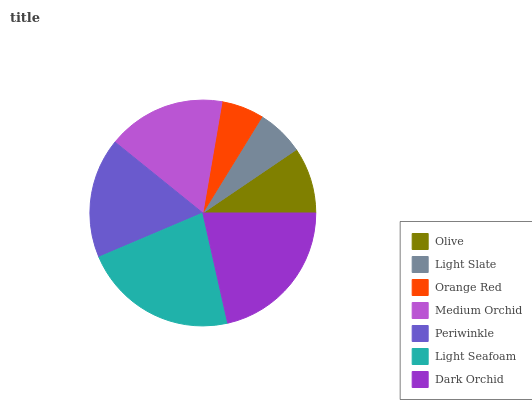Is Orange Red the minimum?
Answer yes or no. Yes. Is Light Seafoam the maximum?
Answer yes or no. Yes. Is Light Slate the minimum?
Answer yes or no. No. Is Light Slate the maximum?
Answer yes or no. No. Is Olive greater than Light Slate?
Answer yes or no. Yes. Is Light Slate less than Olive?
Answer yes or no. Yes. Is Light Slate greater than Olive?
Answer yes or no. No. Is Olive less than Light Slate?
Answer yes or no. No. Is Medium Orchid the high median?
Answer yes or no. Yes. Is Medium Orchid the low median?
Answer yes or no. Yes. Is Orange Red the high median?
Answer yes or no. No. Is Light Seafoam the low median?
Answer yes or no. No. 